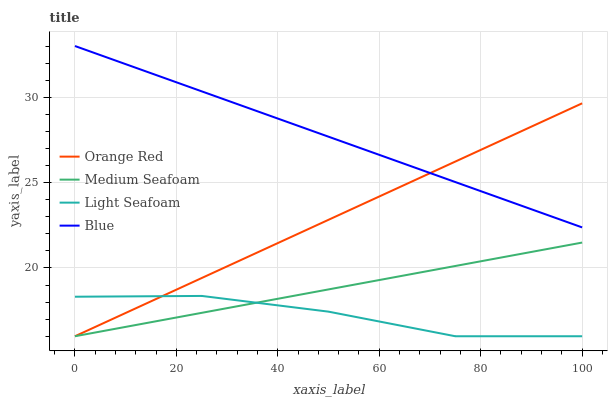Does Light Seafoam have the minimum area under the curve?
Answer yes or no. Yes. Does Blue have the maximum area under the curve?
Answer yes or no. Yes. Does Orange Red have the minimum area under the curve?
Answer yes or no. No. Does Orange Red have the maximum area under the curve?
Answer yes or no. No. Is Medium Seafoam the smoothest?
Answer yes or no. Yes. Is Light Seafoam the roughest?
Answer yes or no. Yes. Is Orange Red the smoothest?
Answer yes or no. No. Is Orange Red the roughest?
Answer yes or no. No. Does Light Seafoam have the lowest value?
Answer yes or no. Yes. Does Blue have the highest value?
Answer yes or no. Yes. Does Orange Red have the highest value?
Answer yes or no. No. Is Medium Seafoam less than Blue?
Answer yes or no. Yes. Is Blue greater than Light Seafoam?
Answer yes or no. Yes. Does Light Seafoam intersect Orange Red?
Answer yes or no. Yes. Is Light Seafoam less than Orange Red?
Answer yes or no. No. Is Light Seafoam greater than Orange Red?
Answer yes or no. No. Does Medium Seafoam intersect Blue?
Answer yes or no. No. 